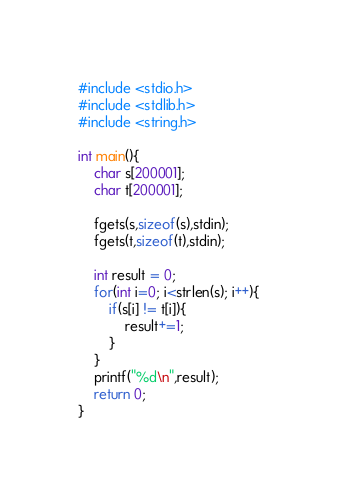Convert code to text. <code><loc_0><loc_0><loc_500><loc_500><_C_>#include <stdio.h>
#include <stdlib.h>
#include <string.h>

int main(){
    char s[200001];
    char t[200001];

    fgets(s,sizeof(s),stdin);
    fgets(t,sizeof(t),stdin);

    int result = 0;
    for(int i=0; i<strlen(s); i++){
        if(s[i] != t[i]){
            result+=1;
        }
    }
    printf("%d\n",result);
    return 0;
}</code> 